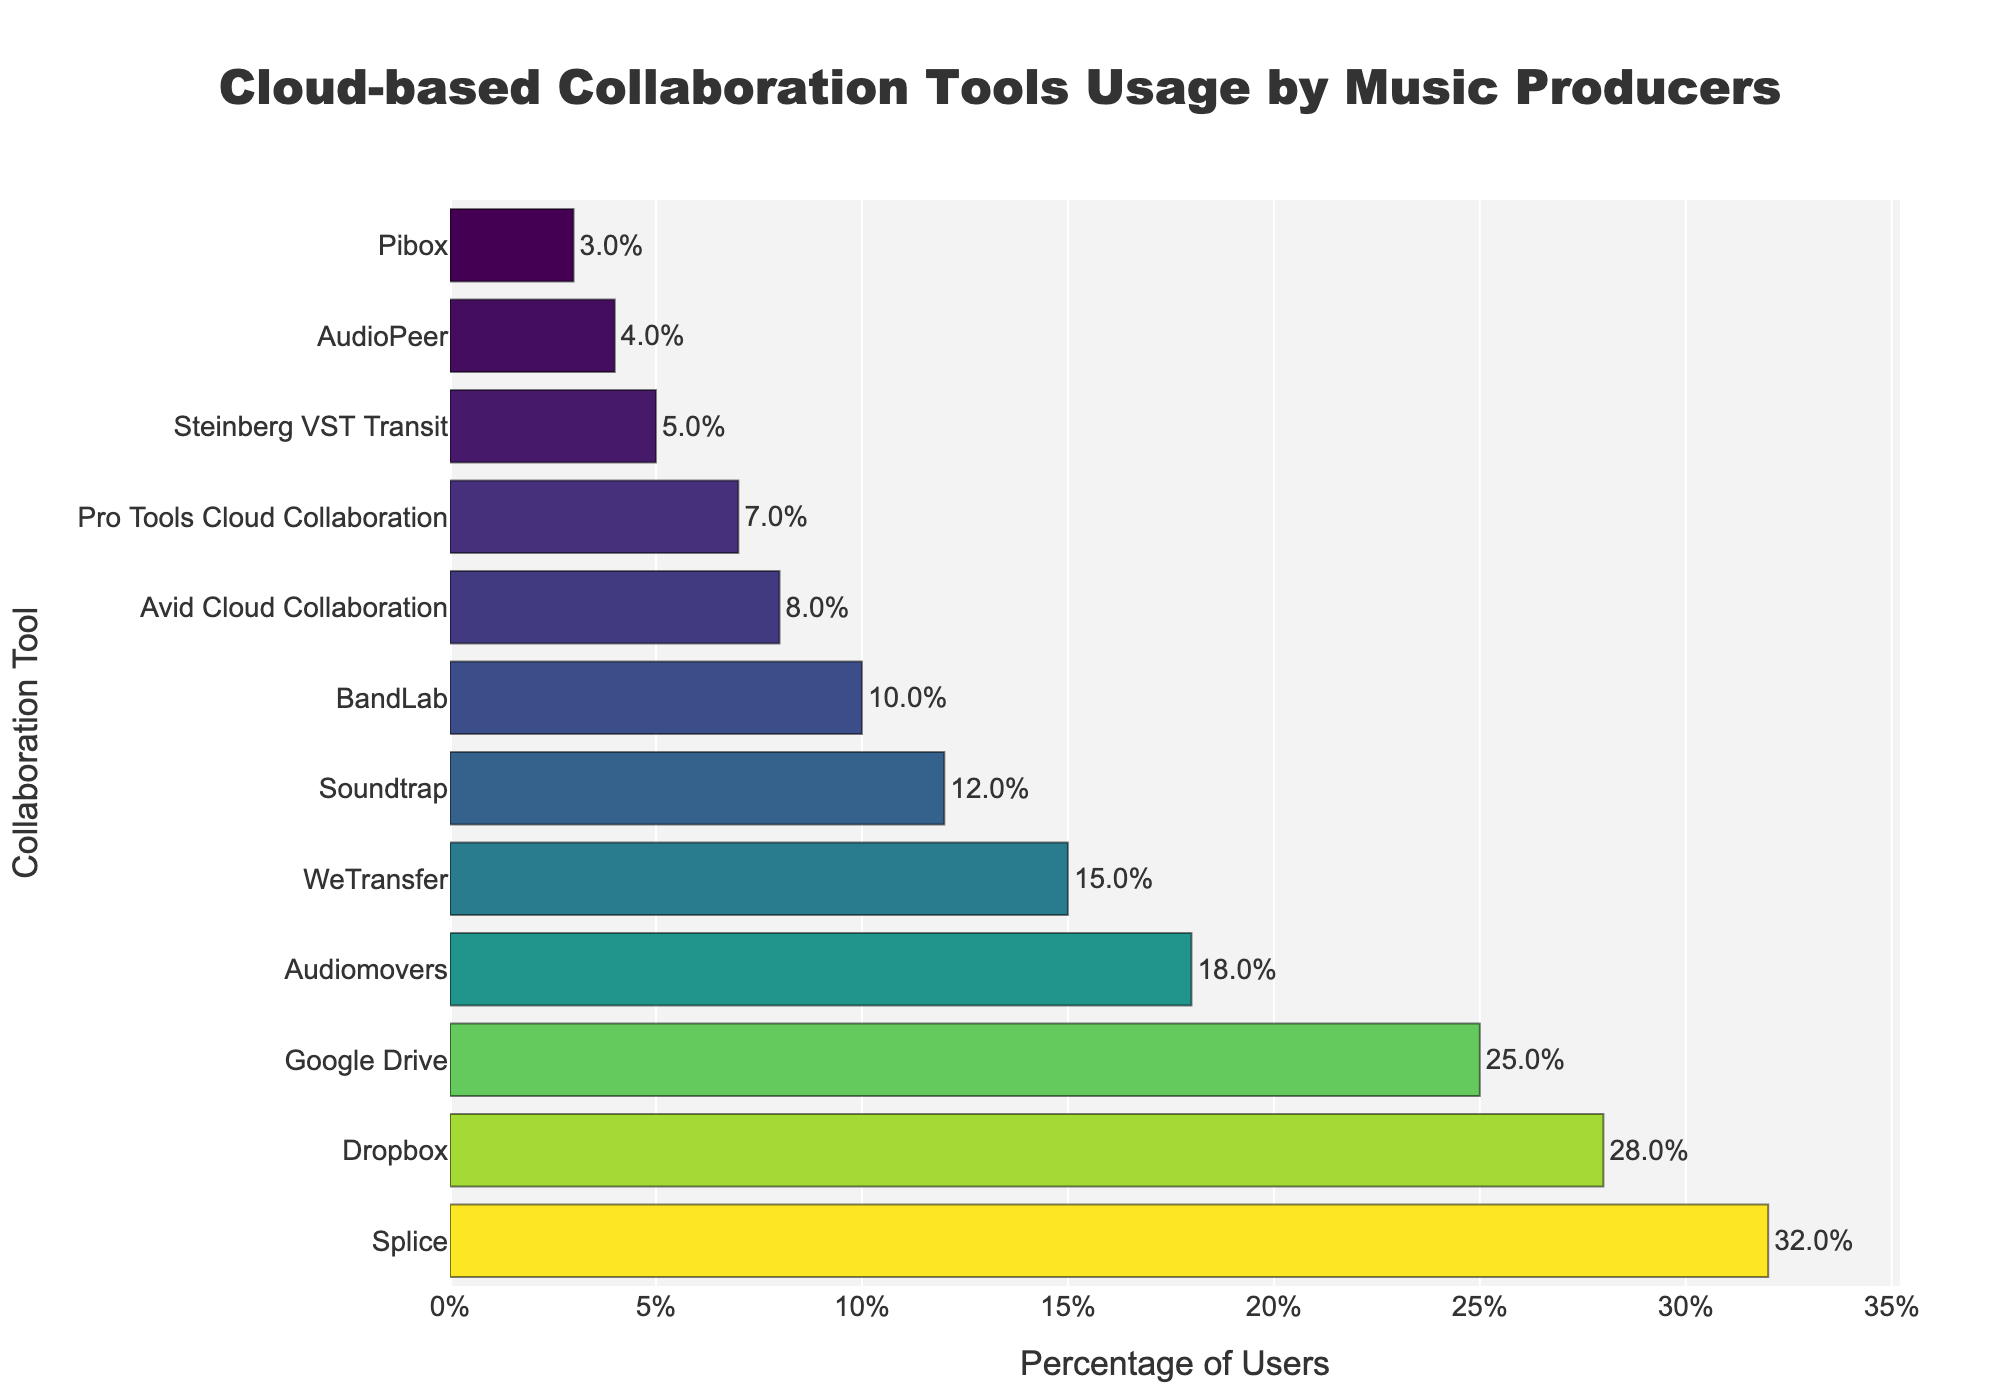What is the percentage difference between Splice and Dropbox? The percentage for Splice is 32%, and for Dropbox, it is 28%. The difference is 32% - 28% = 4%
Answer: 4% Which tool has the lowest usage percentage? Looking at the bar chart, Pibox has the shortest bar, indicating the lowest percentage. Its percentage is 3%.
Answer: Pibox How many tools have a usage percentage of 10% or higher? Counting the bars with a length equal to or greater than 10%: Splice, Dropbox, Google Drive, Audiomovers, WeTransfer, Soundtrap, and BandLab. There are 7 tools.
Answer: 7 What’s the combined percentage of the two tools with the highest usage? The two tools with the highest percentages are Splice (32%) and Dropbox (28%). Their combined percentage is 32% + 28% = 60%.
Answer: 60% Which tool has a higher usage percentage, Soundtrap or Audiomovers? Comparing their bars' lengths: Audiomovers is 18% and Soundtrap is 12%. Audiomovers has a higher percentage.
Answer: Audiomovers What is the difference in percentage between Google Drive and WeTransfer? Google Drive's percentage is 25%, and WeTransfer's is 15%. The difference is 25% - 15% = 10%.
Answer: 10% Are there more tools with a usage percentage above 20% or below 10%? Tools above 20%: Splice, Dropbox, Google Drive (3 tools). Tools below 10%: Avid Cloud Collaboration, Pro Tools Cloud Collaboration, Steinberg VST Transit, AudioPeer, Pibox (5 tools). There are more tools below 10%.
Answer: Below 10% Which tools have a usage percentage between 10% and 20%? Viewing the lengths of the bars that fall within the 10% to 20% range: Audiomovers (18%), WeTransfer (15%), and Soundtrap (12%).
Answer: Audiomovers, WeTransfer, Soundtrap What is the average usage percentage of Splice, Dropbox, and Google Drive? The percentages are Splice (32%), Dropbox (28%), and Google Drive (25%). Their sum is 32 + 28 + 25 = 85. The average is 85/3 ≈ 28.3%.
Answer: 28.3% If a tool needs at least 15% usage to be considered popular, how many tools qualify? Identifying the bars with lengths equal to or greater than 15%: Splice, Dropbox, Google Drive, Audiomovers, and WeTransfer. There are 5 tools.
Answer: 5 